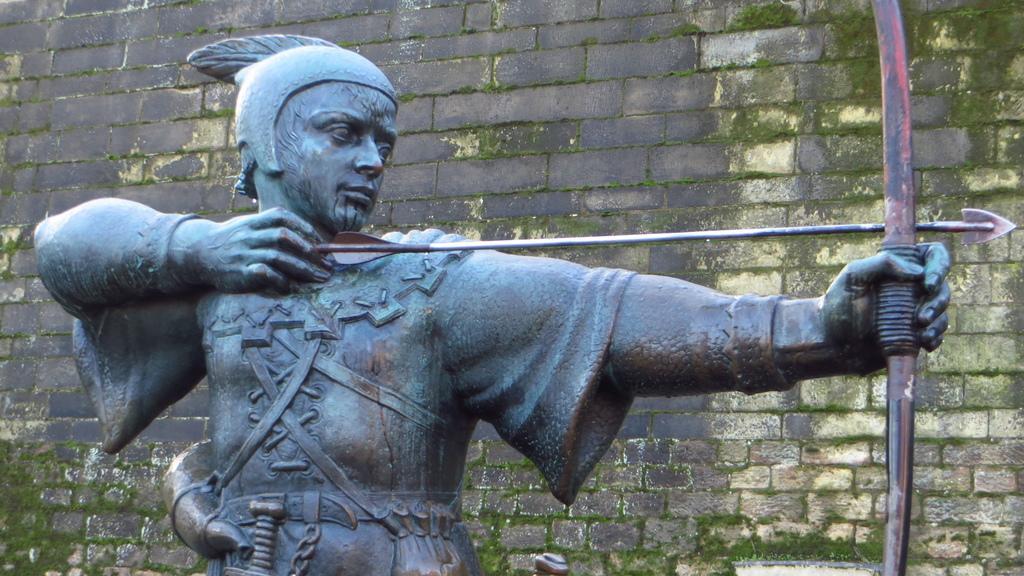Could you give a brief overview of what you see in this image? In this image there is a sculpture of a man towards the bottom of the image, he is holding a bow and an arrow, at the background of the image there is a wall. 